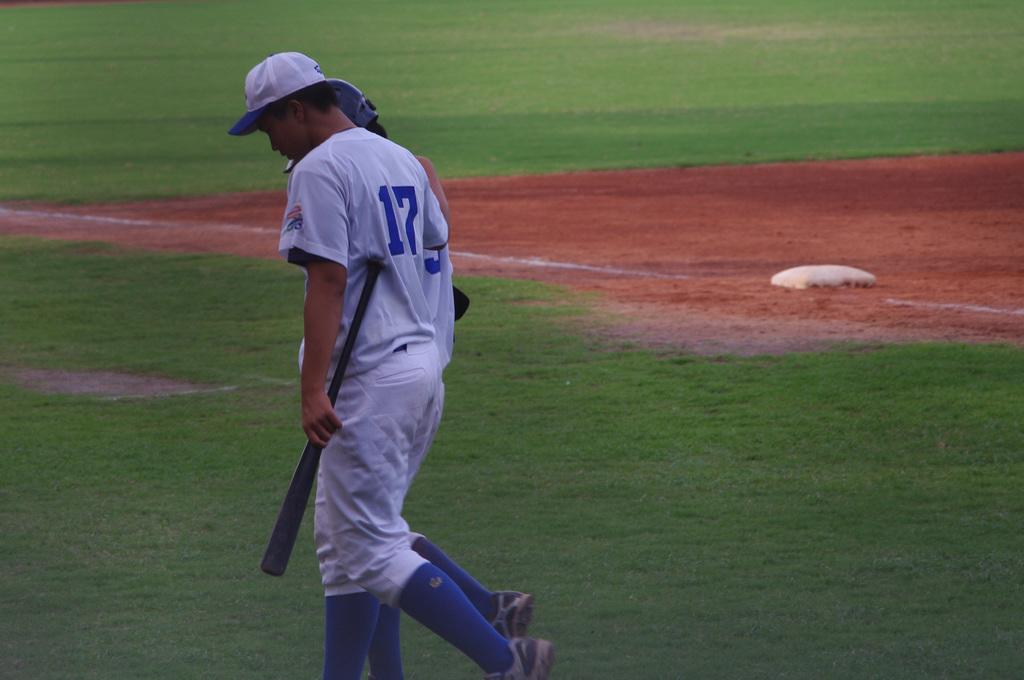What number does the player holding the bat have?
Ensure brevity in your answer.  17. 